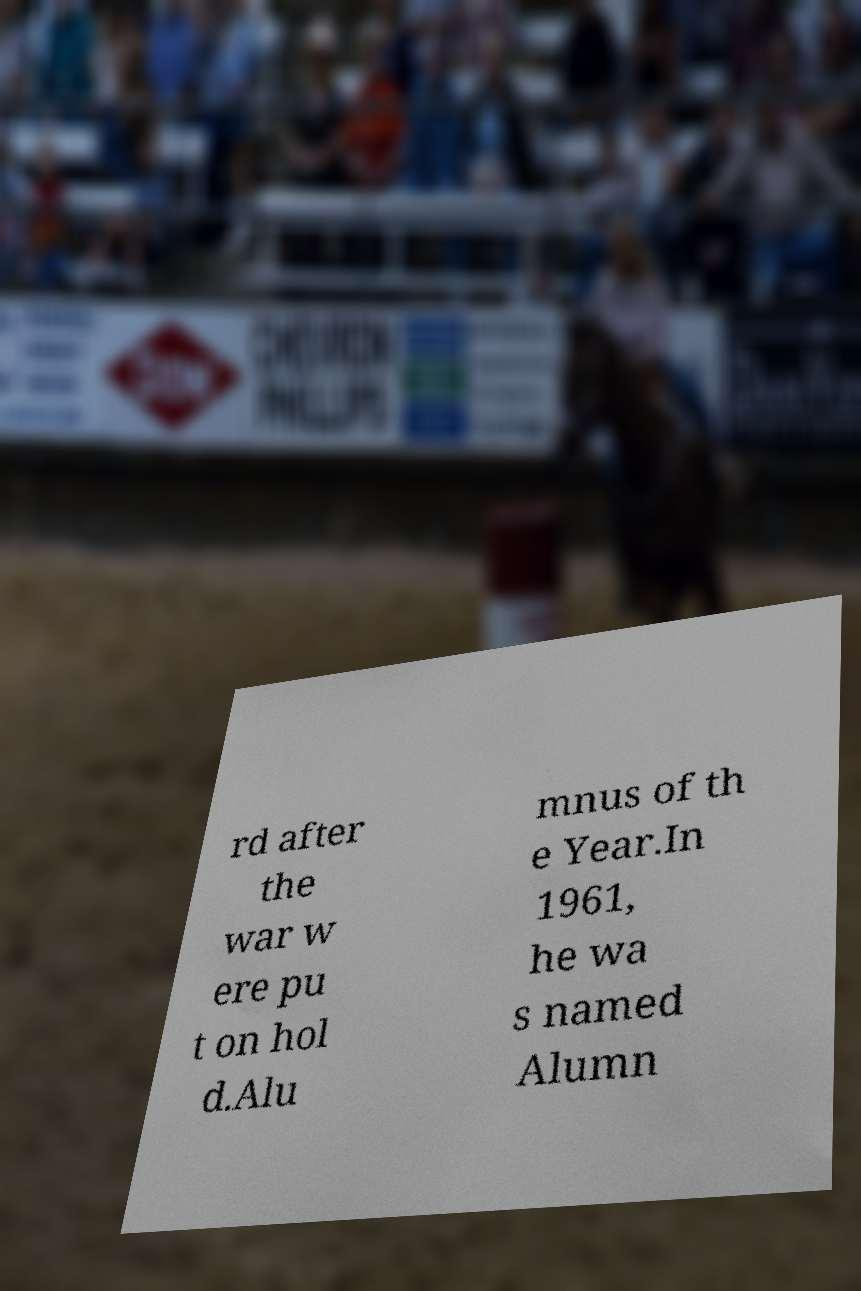Could you extract and type out the text from this image? rd after the war w ere pu t on hol d.Alu mnus of th e Year.In 1961, he wa s named Alumn 